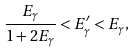<formula> <loc_0><loc_0><loc_500><loc_500>\frac { E _ { \gamma } } { 1 + 2 E _ { \gamma } } < E _ { \gamma } ^ { \prime } < E _ { \gamma } ,</formula> 